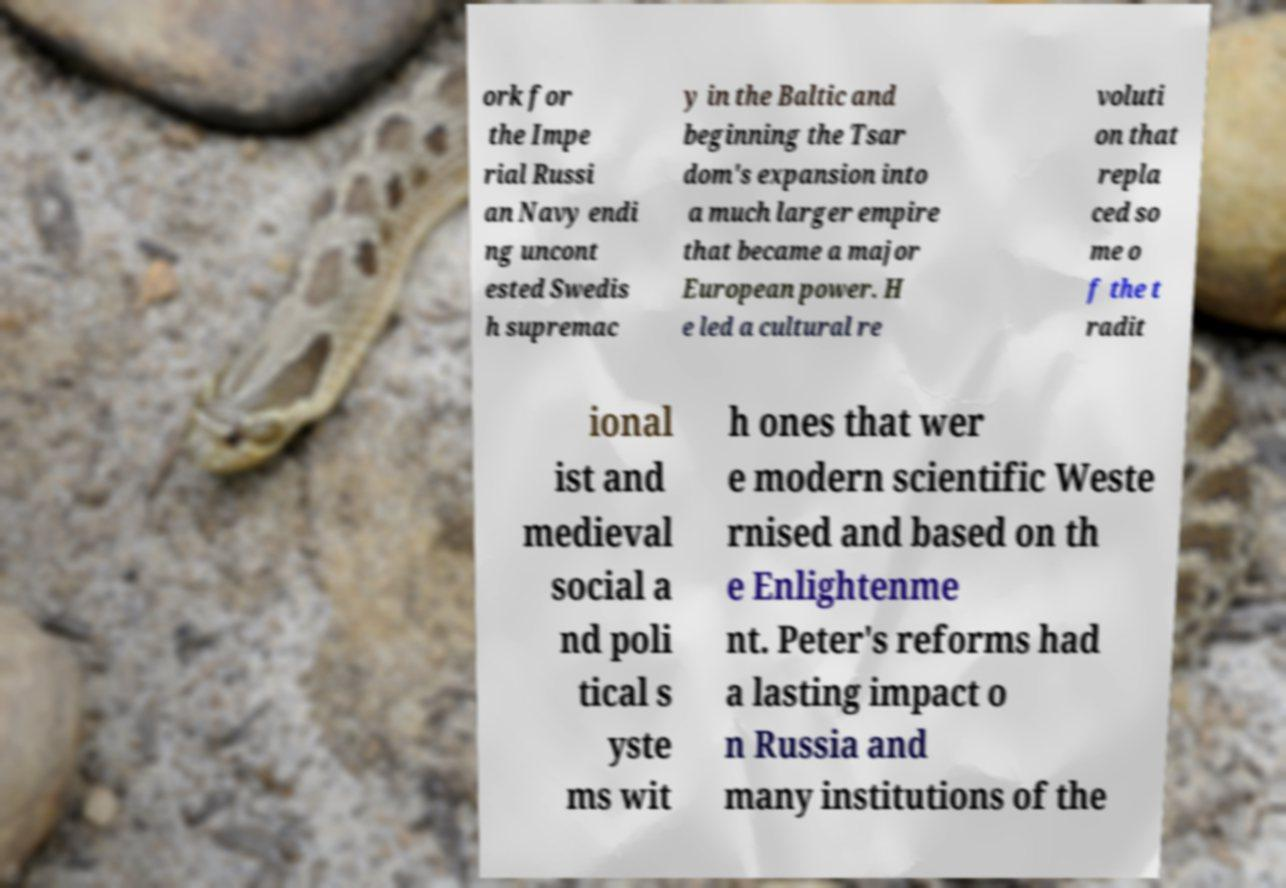There's text embedded in this image that I need extracted. Can you transcribe it verbatim? ork for the Impe rial Russi an Navy endi ng uncont ested Swedis h supremac y in the Baltic and beginning the Tsar dom's expansion into a much larger empire that became a major European power. H e led a cultural re voluti on that repla ced so me o f the t radit ional ist and medieval social a nd poli tical s yste ms wit h ones that wer e modern scientific Weste rnised and based on th e Enlightenme nt. Peter's reforms had a lasting impact o n Russia and many institutions of the 